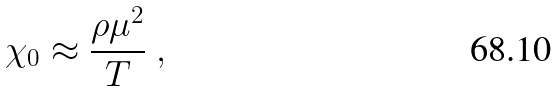Convert formula to latex. <formula><loc_0><loc_0><loc_500><loc_500>\chi _ { 0 } \approx \frac { \rho \mu ^ { 2 } } { T } \ ,</formula> 